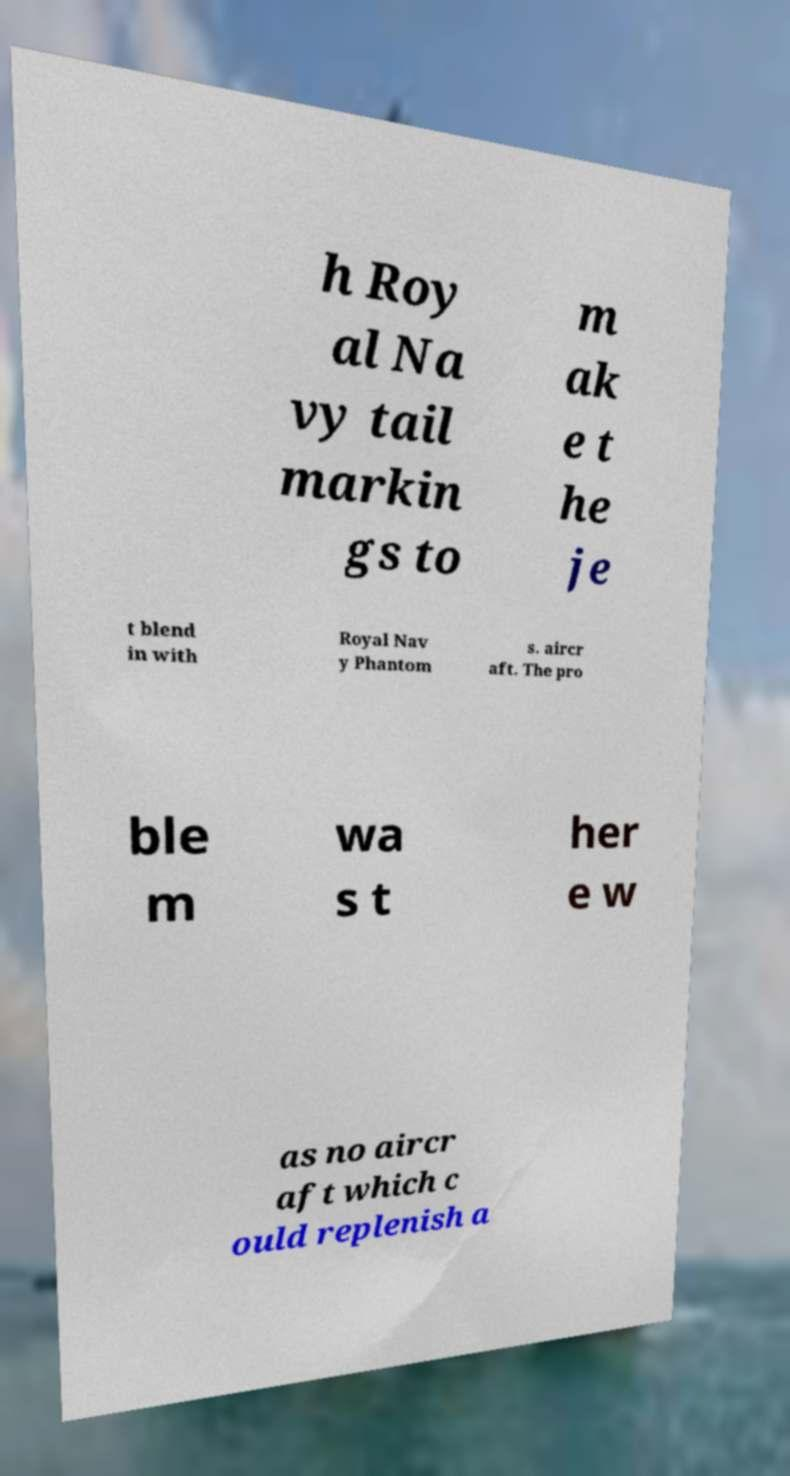Can you accurately transcribe the text from the provided image for me? h Roy al Na vy tail markin gs to m ak e t he je t blend in with Royal Nav y Phantom s. aircr aft. The pro ble m wa s t her e w as no aircr aft which c ould replenish a 